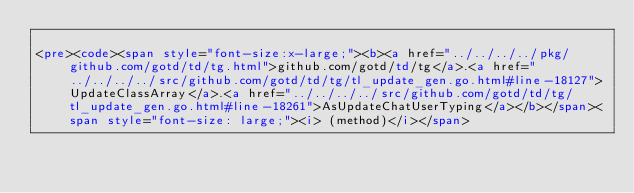Convert code to text. <code><loc_0><loc_0><loc_500><loc_500><_HTML_>
<pre><code><span style="font-size:x-large;"><b><a href="../../../../pkg/github.com/gotd/td/tg.html">github.com/gotd/td/tg</a>.<a href="../../../../src/github.com/gotd/td/tg/tl_update_gen.go.html#line-18127">UpdateClassArray</a>.<a href="../../../../src/github.com/gotd/td/tg/tl_update_gen.go.html#line-18261">AsUpdateChatUserTyping</a></b></span><span style="font-size: large;"><i> (method)</i></span>
</code> 